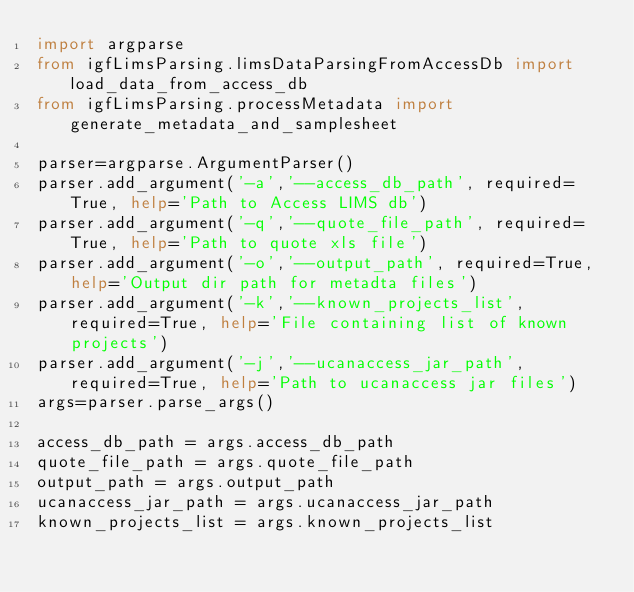<code> <loc_0><loc_0><loc_500><loc_500><_Python_>import argparse
from igfLimsParsing.limsDataParsingFromAccessDb import load_data_from_access_db
from igfLimsParsing.processMetadata import generate_metadata_and_samplesheet

parser=argparse.ArgumentParser()
parser.add_argument('-a','--access_db_path', required=True, help='Path to Access LIMS db')
parser.add_argument('-q','--quote_file_path', required=True, help='Path to quote xls file')
parser.add_argument('-o','--output_path', required=True, help='Output dir path for metadta files')
parser.add_argument('-k','--known_projects_list', required=True, help='File containing list of known projects')
parser.add_argument('-j','--ucanaccess_jar_path', required=True, help='Path to ucanaccess jar files')
args=parser.parse_args()

access_db_path = args.access_db_path
quote_file_path = args.quote_file_path
output_path = args.output_path
ucanaccess_jar_path = args.ucanaccess_jar_path
known_projects_list = args.known_projects_list
</code> 